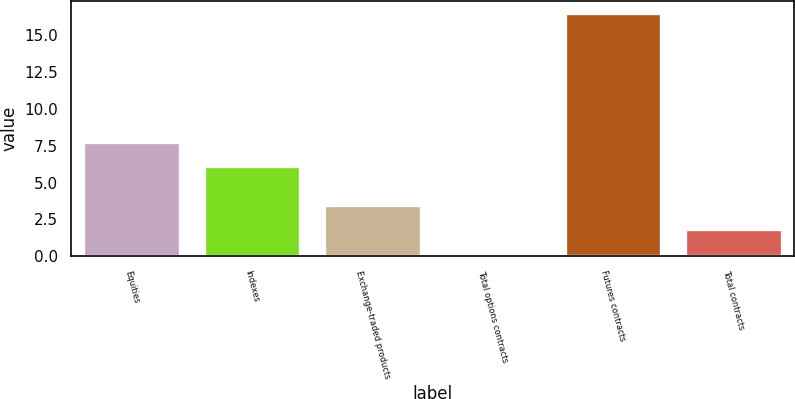<chart> <loc_0><loc_0><loc_500><loc_500><bar_chart><fcel>Equities<fcel>Indexes<fcel>Exchange-traded products<fcel>Total options contracts<fcel>Futures contracts<fcel>Total contracts<nl><fcel>7.73<fcel>6.1<fcel>3.46<fcel>0.2<fcel>16.5<fcel>1.83<nl></chart> 